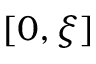<formula> <loc_0><loc_0><loc_500><loc_500>[ 0 , \xi ]</formula> 